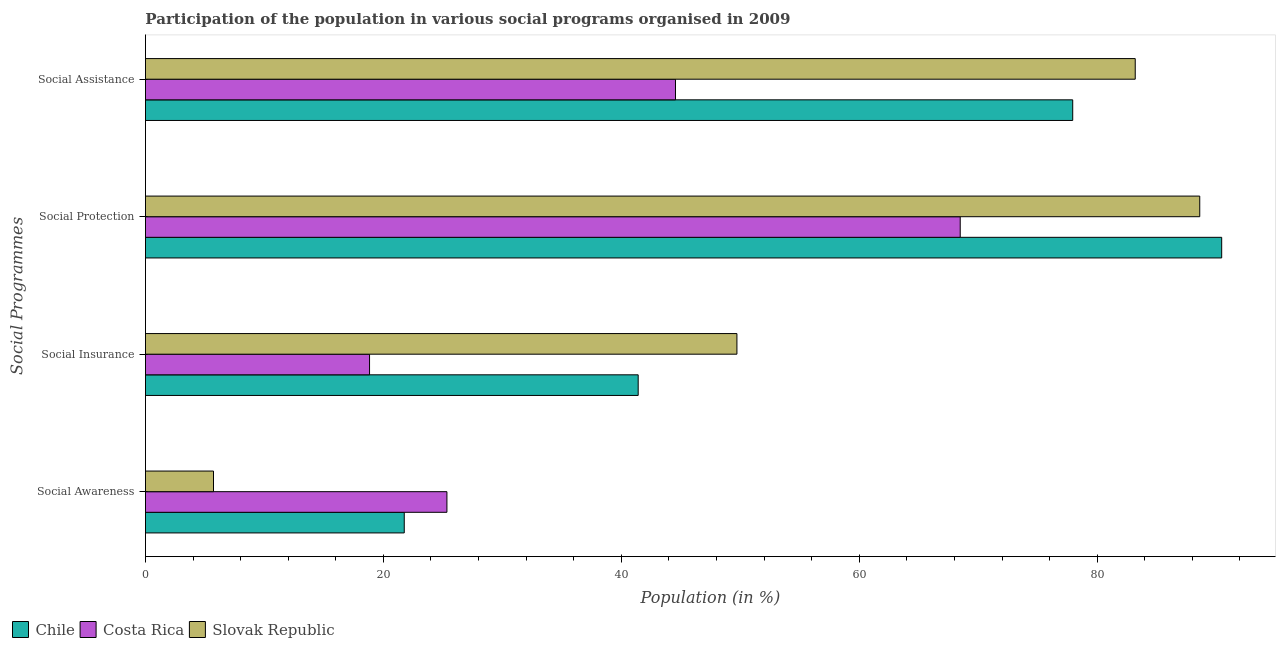How many different coloured bars are there?
Your answer should be compact. 3. How many groups of bars are there?
Offer a very short reply. 4. How many bars are there on the 3rd tick from the top?
Ensure brevity in your answer.  3. What is the label of the 3rd group of bars from the top?
Ensure brevity in your answer.  Social Insurance. What is the participation of population in social assistance programs in Chile?
Provide a short and direct response. 77.94. Across all countries, what is the maximum participation of population in social awareness programs?
Your answer should be very brief. 25.34. Across all countries, what is the minimum participation of population in social assistance programs?
Your answer should be compact. 44.55. In which country was the participation of population in social insurance programs maximum?
Offer a terse response. Slovak Republic. What is the total participation of population in social insurance programs in the graph?
Give a very brief answer. 109.97. What is the difference between the participation of population in social assistance programs in Slovak Republic and that in Costa Rica?
Offer a very short reply. 38.64. What is the difference between the participation of population in social awareness programs in Slovak Republic and the participation of population in social insurance programs in Chile?
Provide a succinct answer. -35.7. What is the average participation of population in social assistance programs per country?
Your answer should be compact. 68.56. What is the difference between the participation of population in social protection programs and participation of population in social awareness programs in Slovak Republic?
Give a very brief answer. 82.9. What is the ratio of the participation of population in social protection programs in Slovak Republic to that in Costa Rica?
Offer a very short reply. 1.29. Is the participation of population in social insurance programs in Costa Rica less than that in Chile?
Your answer should be very brief. Yes. Is the difference between the participation of population in social assistance programs in Slovak Republic and Costa Rica greater than the difference between the participation of population in social awareness programs in Slovak Republic and Costa Rica?
Your answer should be very brief. Yes. What is the difference between the highest and the second highest participation of population in social awareness programs?
Offer a very short reply. 3.59. What is the difference between the highest and the lowest participation of population in social protection programs?
Offer a terse response. 21.98. In how many countries, is the participation of population in social assistance programs greater than the average participation of population in social assistance programs taken over all countries?
Your answer should be very brief. 2. Is it the case that in every country, the sum of the participation of population in social assistance programs and participation of population in social protection programs is greater than the sum of participation of population in social insurance programs and participation of population in social awareness programs?
Your answer should be very brief. Yes. What does the 3rd bar from the top in Social Protection represents?
Provide a succinct answer. Chile. How many bars are there?
Offer a terse response. 12. Are all the bars in the graph horizontal?
Keep it short and to the point. Yes. How many countries are there in the graph?
Provide a succinct answer. 3. What is the difference between two consecutive major ticks on the X-axis?
Your answer should be compact. 20. Are the values on the major ticks of X-axis written in scientific E-notation?
Keep it short and to the point. No. Does the graph contain any zero values?
Your answer should be very brief. No. Does the graph contain grids?
Provide a short and direct response. No. How many legend labels are there?
Your answer should be very brief. 3. What is the title of the graph?
Provide a succinct answer. Participation of the population in various social programs organised in 2009. Does "Madagascar" appear as one of the legend labels in the graph?
Provide a short and direct response. No. What is the label or title of the Y-axis?
Ensure brevity in your answer.  Social Programmes. What is the Population (in %) in Chile in Social Awareness?
Make the answer very short. 21.75. What is the Population (in %) of Costa Rica in Social Awareness?
Keep it short and to the point. 25.34. What is the Population (in %) of Slovak Republic in Social Awareness?
Offer a very short reply. 5.72. What is the Population (in %) of Chile in Social Insurance?
Ensure brevity in your answer.  41.42. What is the Population (in %) in Costa Rica in Social Insurance?
Keep it short and to the point. 18.84. What is the Population (in %) in Slovak Republic in Social Insurance?
Provide a succinct answer. 49.72. What is the Population (in %) in Chile in Social Protection?
Offer a terse response. 90.46. What is the Population (in %) of Costa Rica in Social Protection?
Keep it short and to the point. 68.49. What is the Population (in %) of Slovak Republic in Social Protection?
Make the answer very short. 88.62. What is the Population (in %) in Chile in Social Assistance?
Ensure brevity in your answer.  77.94. What is the Population (in %) in Costa Rica in Social Assistance?
Make the answer very short. 44.55. What is the Population (in %) in Slovak Republic in Social Assistance?
Give a very brief answer. 83.2. Across all Social Programmes, what is the maximum Population (in %) in Chile?
Ensure brevity in your answer.  90.46. Across all Social Programmes, what is the maximum Population (in %) in Costa Rica?
Provide a short and direct response. 68.49. Across all Social Programmes, what is the maximum Population (in %) in Slovak Republic?
Your response must be concise. 88.62. Across all Social Programmes, what is the minimum Population (in %) in Chile?
Ensure brevity in your answer.  21.75. Across all Social Programmes, what is the minimum Population (in %) of Costa Rica?
Offer a very short reply. 18.84. Across all Social Programmes, what is the minimum Population (in %) of Slovak Republic?
Ensure brevity in your answer.  5.72. What is the total Population (in %) in Chile in the graph?
Your answer should be compact. 231.57. What is the total Population (in %) in Costa Rica in the graph?
Make the answer very short. 157.21. What is the total Population (in %) of Slovak Republic in the graph?
Provide a succinct answer. 227.25. What is the difference between the Population (in %) of Chile in Social Awareness and that in Social Insurance?
Keep it short and to the point. -19.66. What is the difference between the Population (in %) in Costa Rica in Social Awareness and that in Social Insurance?
Offer a very short reply. 6.5. What is the difference between the Population (in %) of Slovak Republic in Social Awareness and that in Social Insurance?
Your answer should be compact. -44. What is the difference between the Population (in %) in Chile in Social Awareness and that in Social Protection?
Offer a very short reply. -68.71. What is the difference between the Population (in %) in Costa Rica in Social Awareness and that in Social Protection?
Make the answer very short. -43.15. What is the difference between the Population (in %) in Slovak Republic in Social Awareness and that in Social Protection?
Your answer should be compact. -82.9. What is the difference between the Population (in %) of Chile in Social Awareness and that in Social Assistance?
Keep it short and to the point. -56.19. What is the difference between the Population (in %) of Costa Rica in Social Awareness and that in Social Assistance?
Your answer should be very brief. -19.21. What is the difference between the Population (in %) of Slovak Republic in Social Awareness and that in Social Assistance?
Give a very brief answer. -77.48. What is the difference between the Population (in %) of Chile in Social Insurance and that in Social Protection?
Offer a terse response. -49.05. What is the difference between the Population (in %) in Costa Rica in Social Insurance and that in Social Protection?
Provide a short and direct response. -49.65. What is the difference between the Population (in %) of Slovak Republic in Social Insurance and that in Social Protection?
Make the answer very short. -38.9. What is the difference between the Population (in %) in Chile in Social Insurance and that in Social Assistance?
Make the answer very short. -36.53. What is the difference between the Population (in %) of Costa Rica in Social Insurance and that in Social Assistance?
Your response must be concise. -25.72. What is the difference between the Population (in %) in Slovak Republic in Social Insurance and that in Social Assistance?
Provide a short and direct response. -33.48. What is the difference between the Population (in %) of Chile in Social Protection and that in Social Assistance?
Offer a terse response. 12.52. What is the difference between the Population (in %) of Costa Rica in Social Protection and that in Social Assistance?
Provide a short and direct response. 23.93. What is the difference between the Population (in %) of Slovak Republic in Social Protection and that in Social Assistance?
Keep it short and to the point. 5.42. What is the difference between the Population (in %) of Chile in Social Awareness and the Population (in %) of Costa Rica in Social Insurance?
Provide a short and direct response. 2.92. What is the difference between the Population (in %) of Chile in Social Awareness and the Population (in %) of Slovak Republic in Social Insurance?
Your answer should be very brief. -27.96. What is the difference between the Population (in %) of Costa Rica in Social Awareness and the Population (in %) of Slovak Republic in Social Insurance?
Provide a succinct answer. -24.38. What is the difference between the Population (in %) in Chile in Social Awareness and the Population (in %) in Costa Rica in Social Protection?
Provide a short and direct response. -46.73. What is the difference between the Population (in %) of Chile in Social Awareness and the Population (in %) of Slovak Republic in Social Protection?
Offer a very short reply. -66.87. What is the difference between the Population (in %) of Costa Rica in Social Awareness and the Population (in %) of Slovak Republic in Social Protection?
Keep it short and to the point. -63.28. What is the difference between the Population (in %) of Chile in Social Awareness and the Population (in %) of Costa Rica in Social Assistance?
Offer a very short reply. -22.8. What is the difference between the Population (in %) in Chile in Social Awareness and the Population (in %) in Slovak Republic in Social Assistance?
Provide a succinct answer. -61.44. What is the difference between the Population (in %) of Costa Rica in Social Awareness and the Population (in %) of Slovak Republic in Social Assistance?
Keep it short and to the point. -57.86. What is the difference between the Population (in %) of Chile in Social Insurance and the Population (in %) of Costa Rica in Social Protection?
Your response must be concise. -27.07. What is the difference between the Population (in %) in Chile in Social Insurance and the Population (in %) in Slovak Republic in Social Protection?
Provide a short and direct response. -47.2. What is the difference between the Population (in %) of Costa Rica in Social Insurance and the Population (in %) of Slovak Republic in Social Protection?
Make the answer very short. -69.78. What is the difference between the Population (in %) of Chile in Social Insurance and the Population (in %) of Costa Rica in Social Assistance?
Your answer should be very brief. -3.14. What is the difference between the Population (in %) in Chile in Social Insurance and the Population (in %) in Slovak Republic in Social Assistance?
Your answer should be very brief. -41.78. What is the difference between the Population (in %) in Costa Rica in Social Insurance and the Population (in %) in Slovak Republic in Social Assistance?
Keep it short and to the point. -64.36. What is the difference between the Population (in %) in Chile in Social Protection and the Population (in %) in Costa Rica in Social Assistance?
Offer a very short reply. 45.91. What is the difference between the Population (in %) of Chile in Social Protection and the Population (in %) of Slovak Republic in Social Assistance?
Your answer should be very brief. 7.27. What is the difference between the Population (in %) in Costa Rica in Social Protection and the Population (in %) in Slovak Republic in Social Assistance?
Keep it short and to the point. -14.71. What is the average Population (in %) in Chile per Social Programmes?
Your response must be concise. 57.89. What is the average Population (in %) of Costa Rica per Social Programmes?
Offer a terse response. 39.3. What is the average Population (in %) in Slovak Republic per Social Programmes?
Provide a short and direct response. 56.81. What is the difference between the Population (in %) in Chile and Population (in %) in Costa Rica in Social Awareness?
Provide a succinct answer. -3.59. What is the difference between the Population (in %) in Chile and Population (in %) in Slovak Republic in Social Awareness?
Your response must be concise. 16.03. What is the difference between the Population (in %) of Costa Rica and Population (in %) of Slovak Republic in Social Awareness?
Give a very brief answer. 19.62. What is the difference between the Population (in %) in Chile and Population (in %) in Costa Rica in Social Insurance?
Give a very brief answer. 22.58. What is the difference between the Population (in %) in Chile and Population (in %) in Slovak Republic in Social Insurance?
Give a very brief answer. -8.3. What is the difference between the Population (in %) of Costa Rica and Population (in %) of Slovak Republic in Social Insurance?
Ensure brevity in your answer.  -30.88. What is the difference between the Population (in %) of Chile and Population (in %) of Costa Rica in Social Protection?
Provide a short and direct response. 21.98. What is the difference between the Population (in %) of Chile and Population (in %) of Slovak Republic in Social Protection?
Your answer should be compact. 1.84. What is the difference between the Population (in %) of Costa Rica and Population (in %) of Slovak Republic in Social Protection?
Provide a short and direct response. -20.13. What is the difference between the Population (in %) of Chile and Population (in %) of Costa Rica in Social Assistance?
Give a very brief answer. 33.39. What is the difference between the Population (in %) of Chile and Population (in %) of Slovak Republic in Social Assistance?
Give a very brief answer. -5.26. What is the difference between the Population (in %) in Costa Rica and Population (in %) in Slovak Republic in Social Assistance?
Your answer should be very brief. -38.64. What is the ratio of the Population (in %) in Chile in Social Awareness to that in Social Insurance?
Offer a very short reply. 0.53. What is the ratio of the Population (in %) of Costa Rica in Social Awareness to that in Social Insurance?
Give a very brief answer. 1.35. What is the ratio of the Population (in %) of Slovak Republic in Social Awareness to that in Social Insurance?
Provide a short and direct response. 0.12. What is the ratio of the Population (in %) of Chile in Social Awareness to that in Social Protection?
Your answer should be very brief. 0.24. What is the ratio of the Population (in %) of Costa Rica in Social Awareness to that in Social Protection?
Give a very brief answer. 0.37. What is the ratio of the Population (in %) of Slovak Republic in Social Awareness to that in Social Protection?
Your answer should be compact. 0.06. What is the ratio of the Population (in %) of Chile in Social Awareness to that in Social Assistance?
Give a very brief answer. 0.28. What is the ratio of the Population (in %) of Costa Rica in Social Awareness to that in Social Assistance?
Your answer should be compact. 0.57. What is the ratio of the Population (in %) in Slovak Republic in Social Awareness to that in Social Assistance?
Offer a very short reply. 0.07. What is the ratio of the Population (in %) of Chile in Social Insurance to that in Social Protection?
Offer a terse response. 0.46. What is the ratio of the Population (in %) in Costa Rica in Social Insurance to that in Social Protection?
Your answer should be very brief. 0.28. What is the ratio of the Population (in %) in Slovak Republic in Social Insurance to that in Social Protection?
Your answer should be compact. 0.56. What is the ratio of the Population (in %) in Chile in Social Insurance to that in Social Assistance?
Provide a succinct answer. 0.53. What is the ratio of the Population (in %) of Costa Rica in Social Insurance to that in Social Assistance?
Provide a succinct answer. 0.42. What is the ratio of the Population (in %) in Slovak Republic in Social Insurance to that in Social Assistance?
Provide a succinct answer. 0.6. What is the ratio of the Population (in %) in Chile in Social Protection to that in Social Assistance?
Provide a short and direct response. 1.16. What is the ratio of the Population (in %) in Costa Rica in Social Protection to that in Social Assistance?
Your answer should be very brief. 1.54. What is the ratio of the Population (in %) in Slovak Republic in Social Protection to that in Social Assistance?
Ensure brevity in your answer.  1.07. What is the difference between the highest and the second highest Population (in %) in Chile?
Give a very brief answer. 12.52. What is the difference between the highest and the second highest Population (in %) of Costa Rica?
Your answer should be compact. 23.93. What is the difference between the highest and the second highest Population (in %) of Slovak Republic?
Keep it short and to the point. 5.42. What is the difference between the highest and the lowest Population (in %) in Chile?
Keep it short and to the point. 68.71. What is the difference between the highest and the lowest Population (in %) of Costa Rica?
Ensure brevity in your answer.  49.65. What is the difference between the highest and the lowest Population (in %) of Slovak Republic?
Your answer should be very brief. 82.9. 